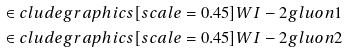<formula> <loc_0><loc_0><loc_500><loc_500>\in c l u d e g r a p h i c s [ s c a l e = 0 . 4 5 ] { W I - 2 g l u o n 1 } \\ \in c l u d e g r a p h i c s [ s c a l e = 0 . 4 5 ] { W I - 2 g l u o n 2 }</formula> 